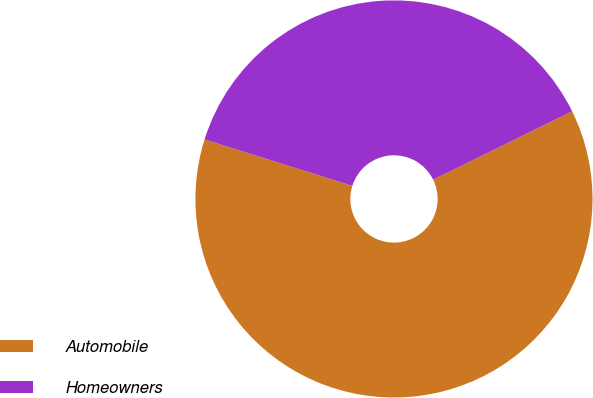<chart> <loc_0><loc_0><loc_500><loc_500><pie_chart><fcel>Automobile<fcel>Homeowners<nl><fcel>62.12%<fcel>37.88%<nl></chart> 